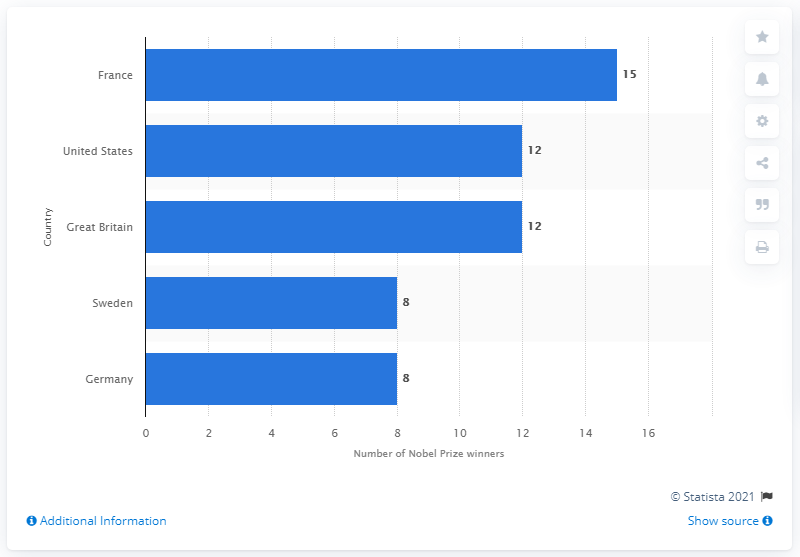Mention a couple of crucial points in this snapshot. France has the most Nobel Prize winners in Literature. 